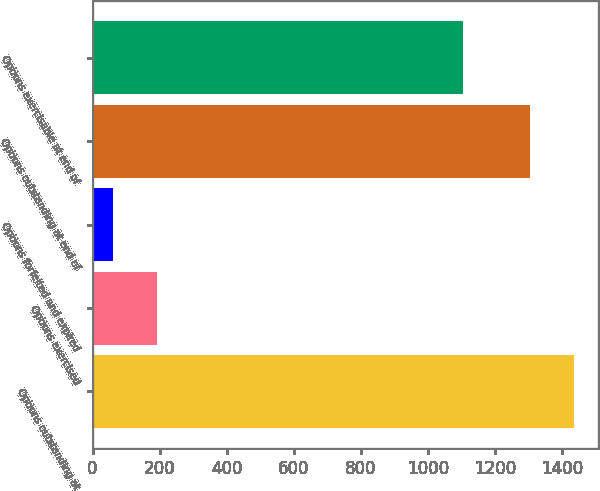Convert chart to OTSL. <chart><loc_0><loc_0><loc_500><loc_500><bar_chart><fcel>Options outstanding at<fcel>Options exercised<fcel>Options forfeited and expired<fcel>Options outstanding at end of<fcel>Options exercisable at end of<nl><fcel>1436.1<fcel>191.1<fcel>60<fcel>1305<fcel>1106<nl></chart> 